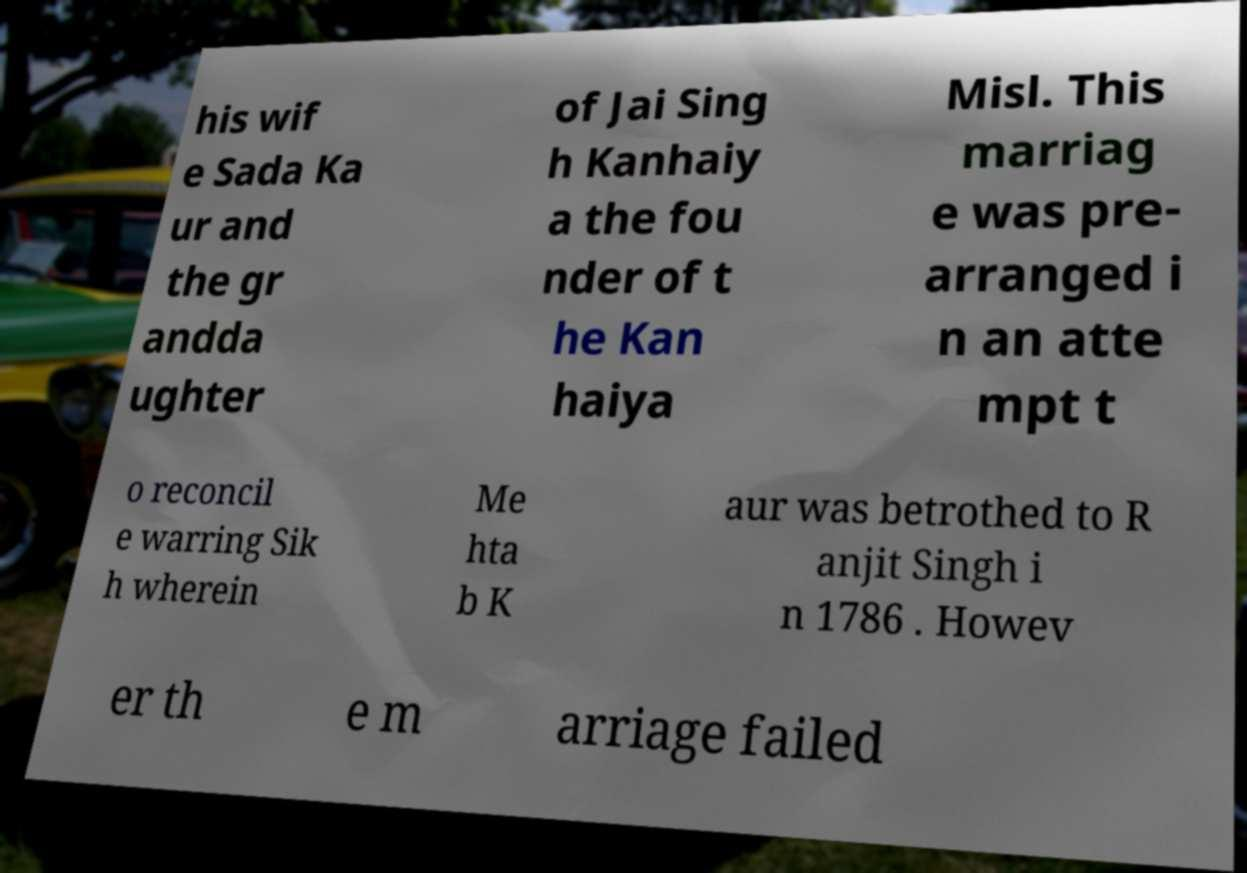What messages or text are displayed in this image? I need them in a readable, typed format. his wif e Sada Ka ur and the gr andda ughter of Jai Sing h Kanhaiy a the fou nder of t he Kan haiya Misl. This marriag e was pre- arranged i n an atte mpt t o reconcil e warring Sik h wherein Me hta b K aur was betrothed to R anjit Singh i n 1786 . Howev er th e m arriage failed 